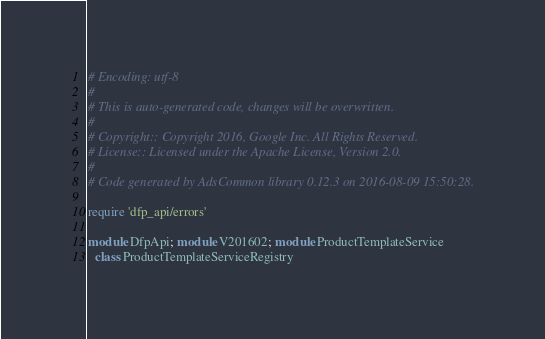<code> <loc_0><loc_0><loc_500><loc_500><_Ruby_># Encoding: utf-8
#
# This is auto-generated code, changes will be overwritten.
#
# Copyright:: Copyright 2016, Google Inc. All Rights Reserved.
# License:: Licensed under the Apache License, Version 2.0.
#
# Code generated by AdsCommon library 0.12.3 on 2016-08-09 15:50:28.

require 'dfp_api/errors'

module DfpApi; module V201602; module ProductTemplateService
  class ProductTemplateServiceRegistry</code> 